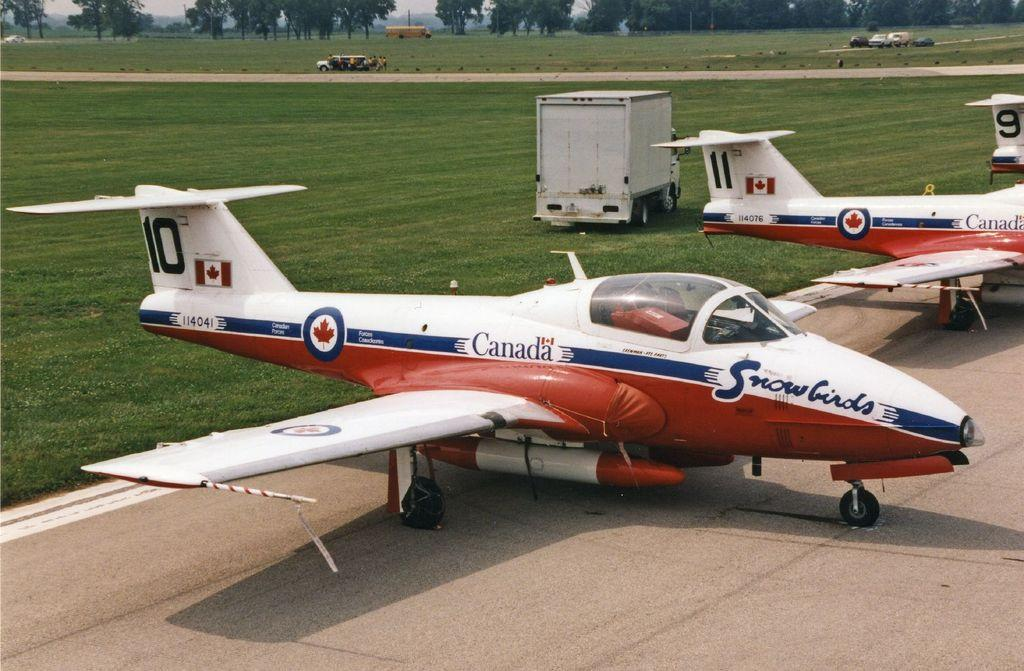<image>
Create a compact narrative representing the image presented. The Canadian Snowbirds fleet is parked next to each other in numerical order. 